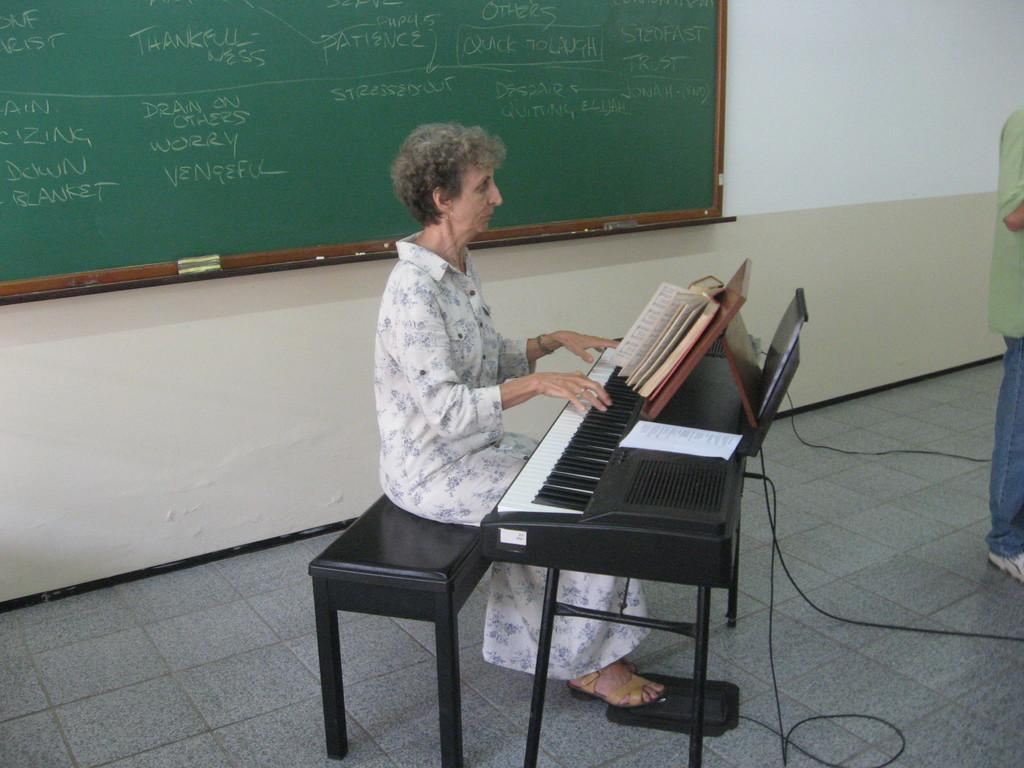Who is the main subject in the image? There is a woman in the image. What is the woman doing in the image? The woman is seated on a stool and playing a piano. What object is in front of the woman? There is a book in front of the woman. Who else is present in the image? There is a man standing in the image. What can be seen behind the woman? There is a board behind the woman. Can you tell me how many legs the boat has in the image? There is no boat present in the image, so it is not possible to determine the number of legs it might have. 